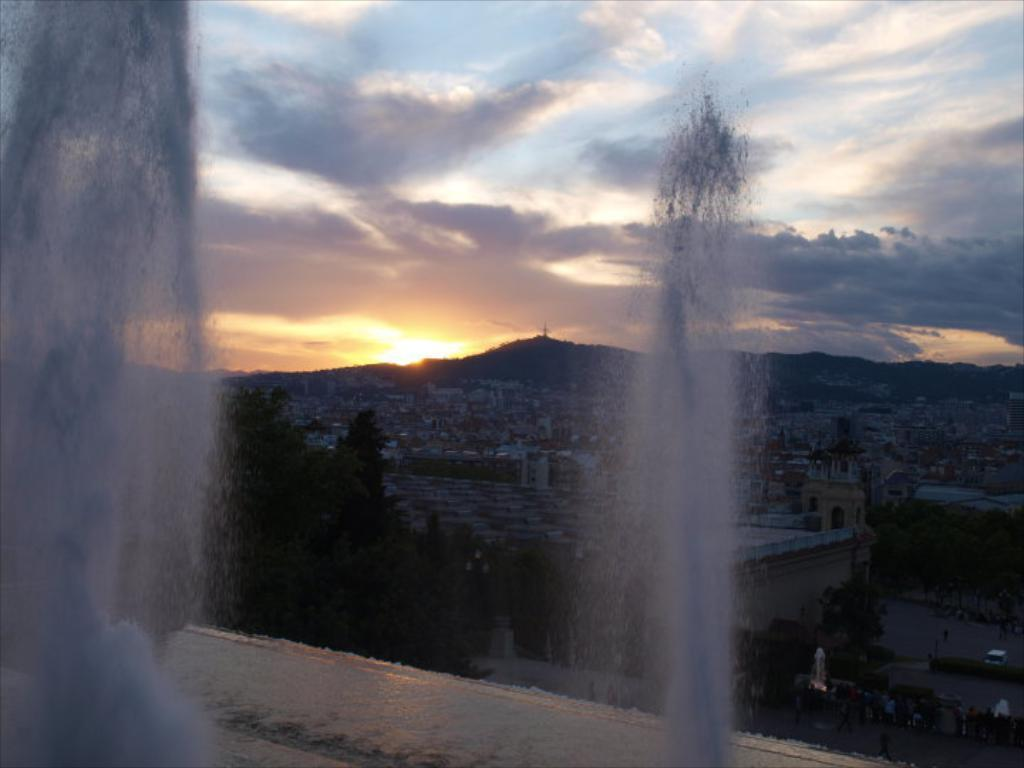What is located in the foreground of the image? There are fountains in the foreground of the image. What can be seen in the background of the image? There are houses, trees, people, and the sky visible in the background of the image. Can you describe the celestial body visible in the sky? The sun is observable in the sky. How many pears are visible in the image? There are no pears present in the image. What is the digestive system of the people in the image? The image does not provide information about the digestive system of the people; it only shows their presence in the background. 